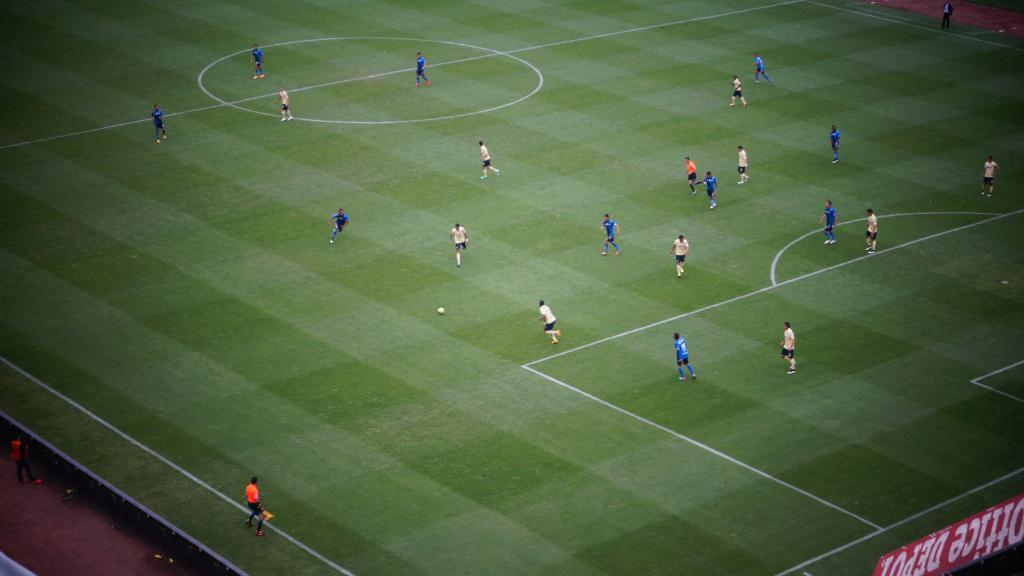What are the people in the image doing? The people in the image are playing football. What sport are the players engaged in? The players are playing football. Where is the football game taking place? The football game is taking place on a ground. What type of dinosaurs can be seen in the image? There are no dinosaurs present in the image; it features a football game. Can you describe the level of detail in the players' uniforms? The provided facts do not mention any specific details about the players' uniforms, so it is not possible to answer this question. 